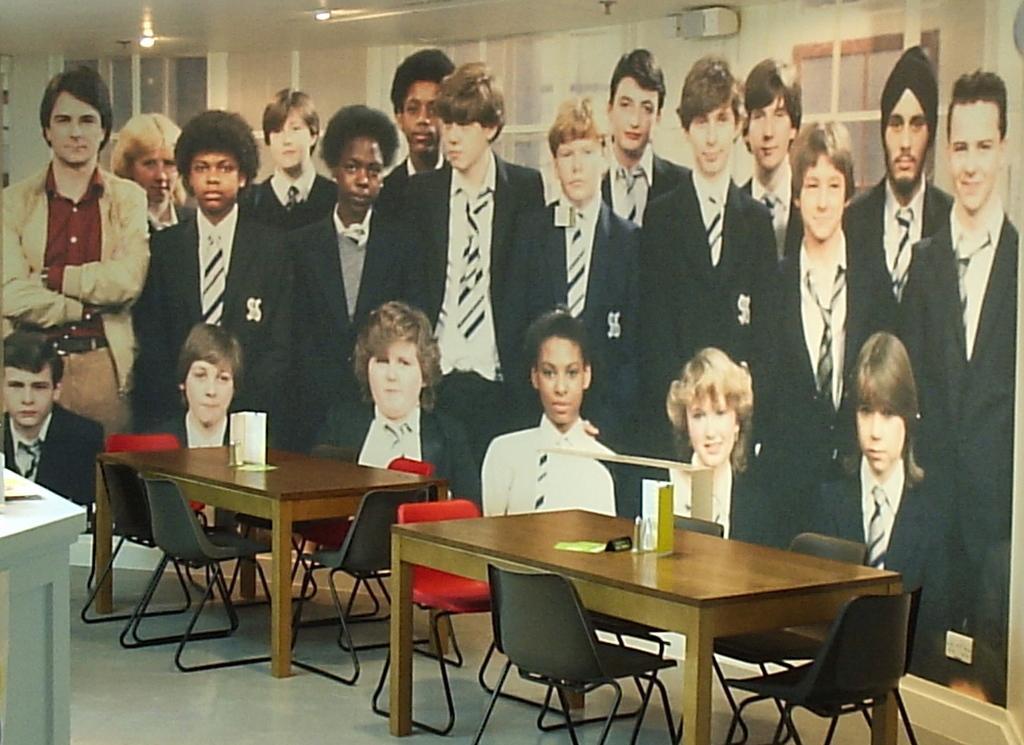Please provide a concise description of this image. In this image I can see the board. There are group of people on that board. In front of that board there are two tables and the chair. 